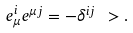Convert formula to latex. <formula><loc_0><loc_0><loc_500><loc_500>e _ { \mu } ^ { i } e ^ { \mu j } = - \delta ^ { i j } \ > .</formula> 